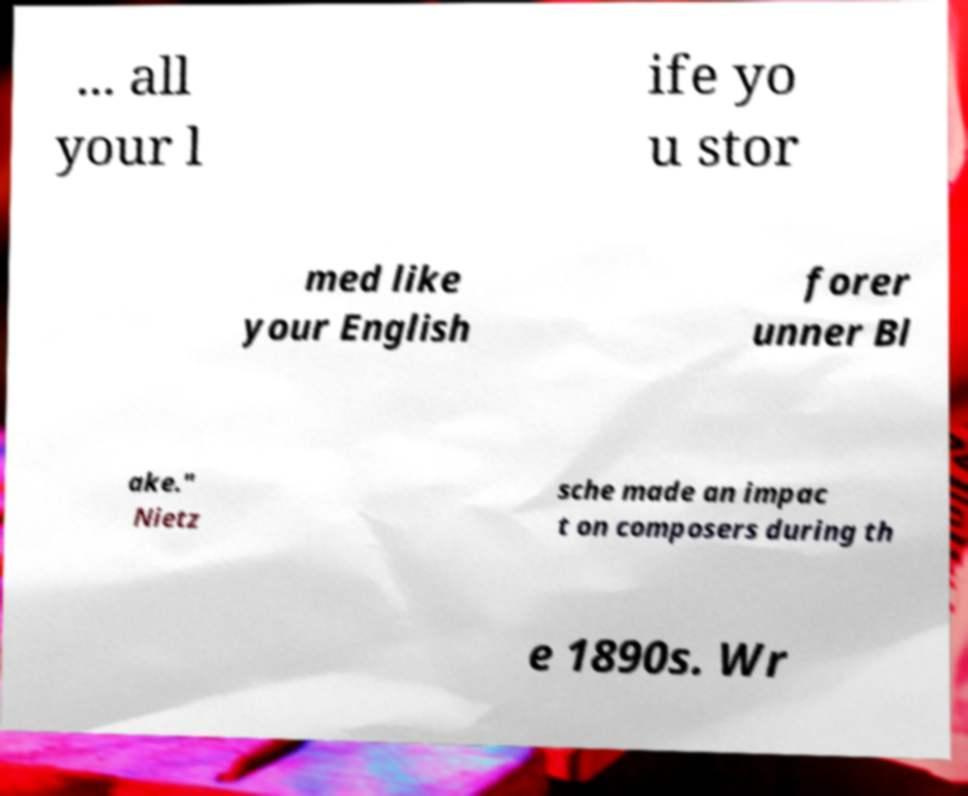Can you read and provide the text displayed in the image?This photo seems to have some interesting text. Can you extract and type it out for me? ... all your l ife yo u stor med like your English forer unner Bl ake." Nietz sche made an impac t on composers during th e 1890s. Wr 